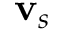<formula> <loc_0><loc_0><loc_500><loc_500>{ v } _ { s }</formula> 